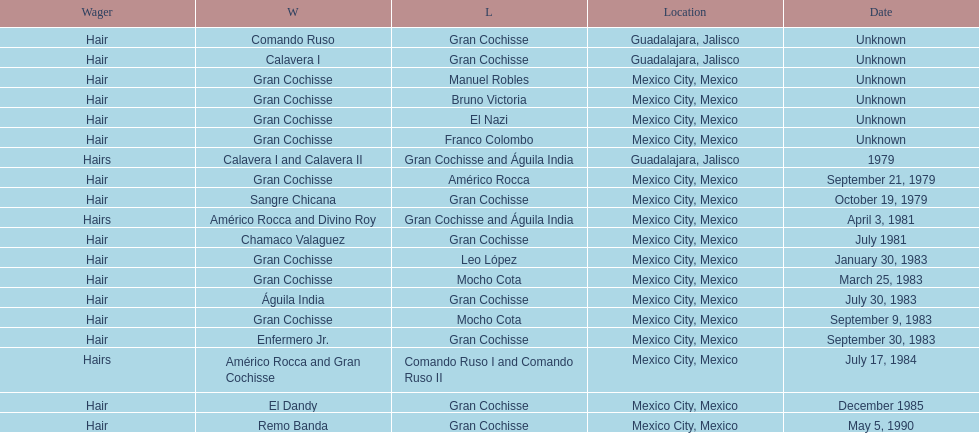Could you parse the entire table as a dict? {'header': ['Wager', 'W', 'L', 'Location', 'Date'], 'rows': [['Hair', 'Comando Ruso', 'Gran Cochisse', 'Guadalajara, Jalisco', 'Unknown'], ['Hair', 'Calavera I', 'Gran Cochisse', 'Guadalajara, Jalisco', 'Unknown'], ['Hair', 'Gran Cochisse', 'Manuel Robles', 'Mexico City, Mexico', 'Unknown'], ['Hair', 'Gran Cochisse', 'Bruno Victoria', 'Mexico City, Mexico', 'Unknown'], ['Hair', 'Gran Cochisse', 'El Nazi', 'Mexico City, Mexico', 'Unknown'], ['Hair', 'Gran Cochisse', 'Franco Colombo', 'Mexico City, Mexico', 'Unknown'], ['Hairs', 'Calavera I and Calavera II', 'Gran Cochisse and Águila India', 'Guadalajara, Jalisco', '1979'], ['Hair', 'Gran Cochisse', 'Américo Rocca', 'Mexico City, Mexico', 'September 21, 1979'], ['Hair', 'Sangre Chicana', 'Gran Cochisse', 'Mexico City, Mexico', 'October 19, 1979'], ['Hairs', 'Américo Rocca and Divino Roy', 'Gran Cochisse and Águila India', 'Mexico City, Mexico', 'April 3, 1981'], ['Hair', 'Chamaco Valaguez', 'Gran Cochisse', 'Mexico City, Mexico', 'July 1981'], ['Hair', 'Gran Cochisse', 'Leo López', 'Mexico City, Mexico', 'January 30, 1983'], ['Hair', 'Gran Cochisse', 'Mocho Cota', 'Mexico City, Mexico', 'March 25, 1983'], ['Hair', 'Águila India', 'Gran Cochisse', 'Mexico City, Mexico', 'July 30, 1983'], ['Hair', 'Gran Cochisse', 'Mocho Cota', 'Mexico City, Mexico', 'September 9, 1983'], ['Hair', 'Enfermero Jr.', 'Gran Cochisse', 'Mexico City, Mexico', 'September 30, 1983'], ['Hairs', 'Américo Rocca and Gran Cochisse', 'Comando Ruso I and Comando Ruso II', 'Mexico City, Mexico', 'July 17, 1984'], ['Hair', 'El Dandy', 'Gran Cochisse', 'Mexico City, Mexico', 'December 1985'], ['Hair', 'Remo Banda', 'Gran Cochisse', 'Mexico City, Mexico', 'May 5, 1990']]} Before bruno victoria was defeated, how many people had won? 3. 